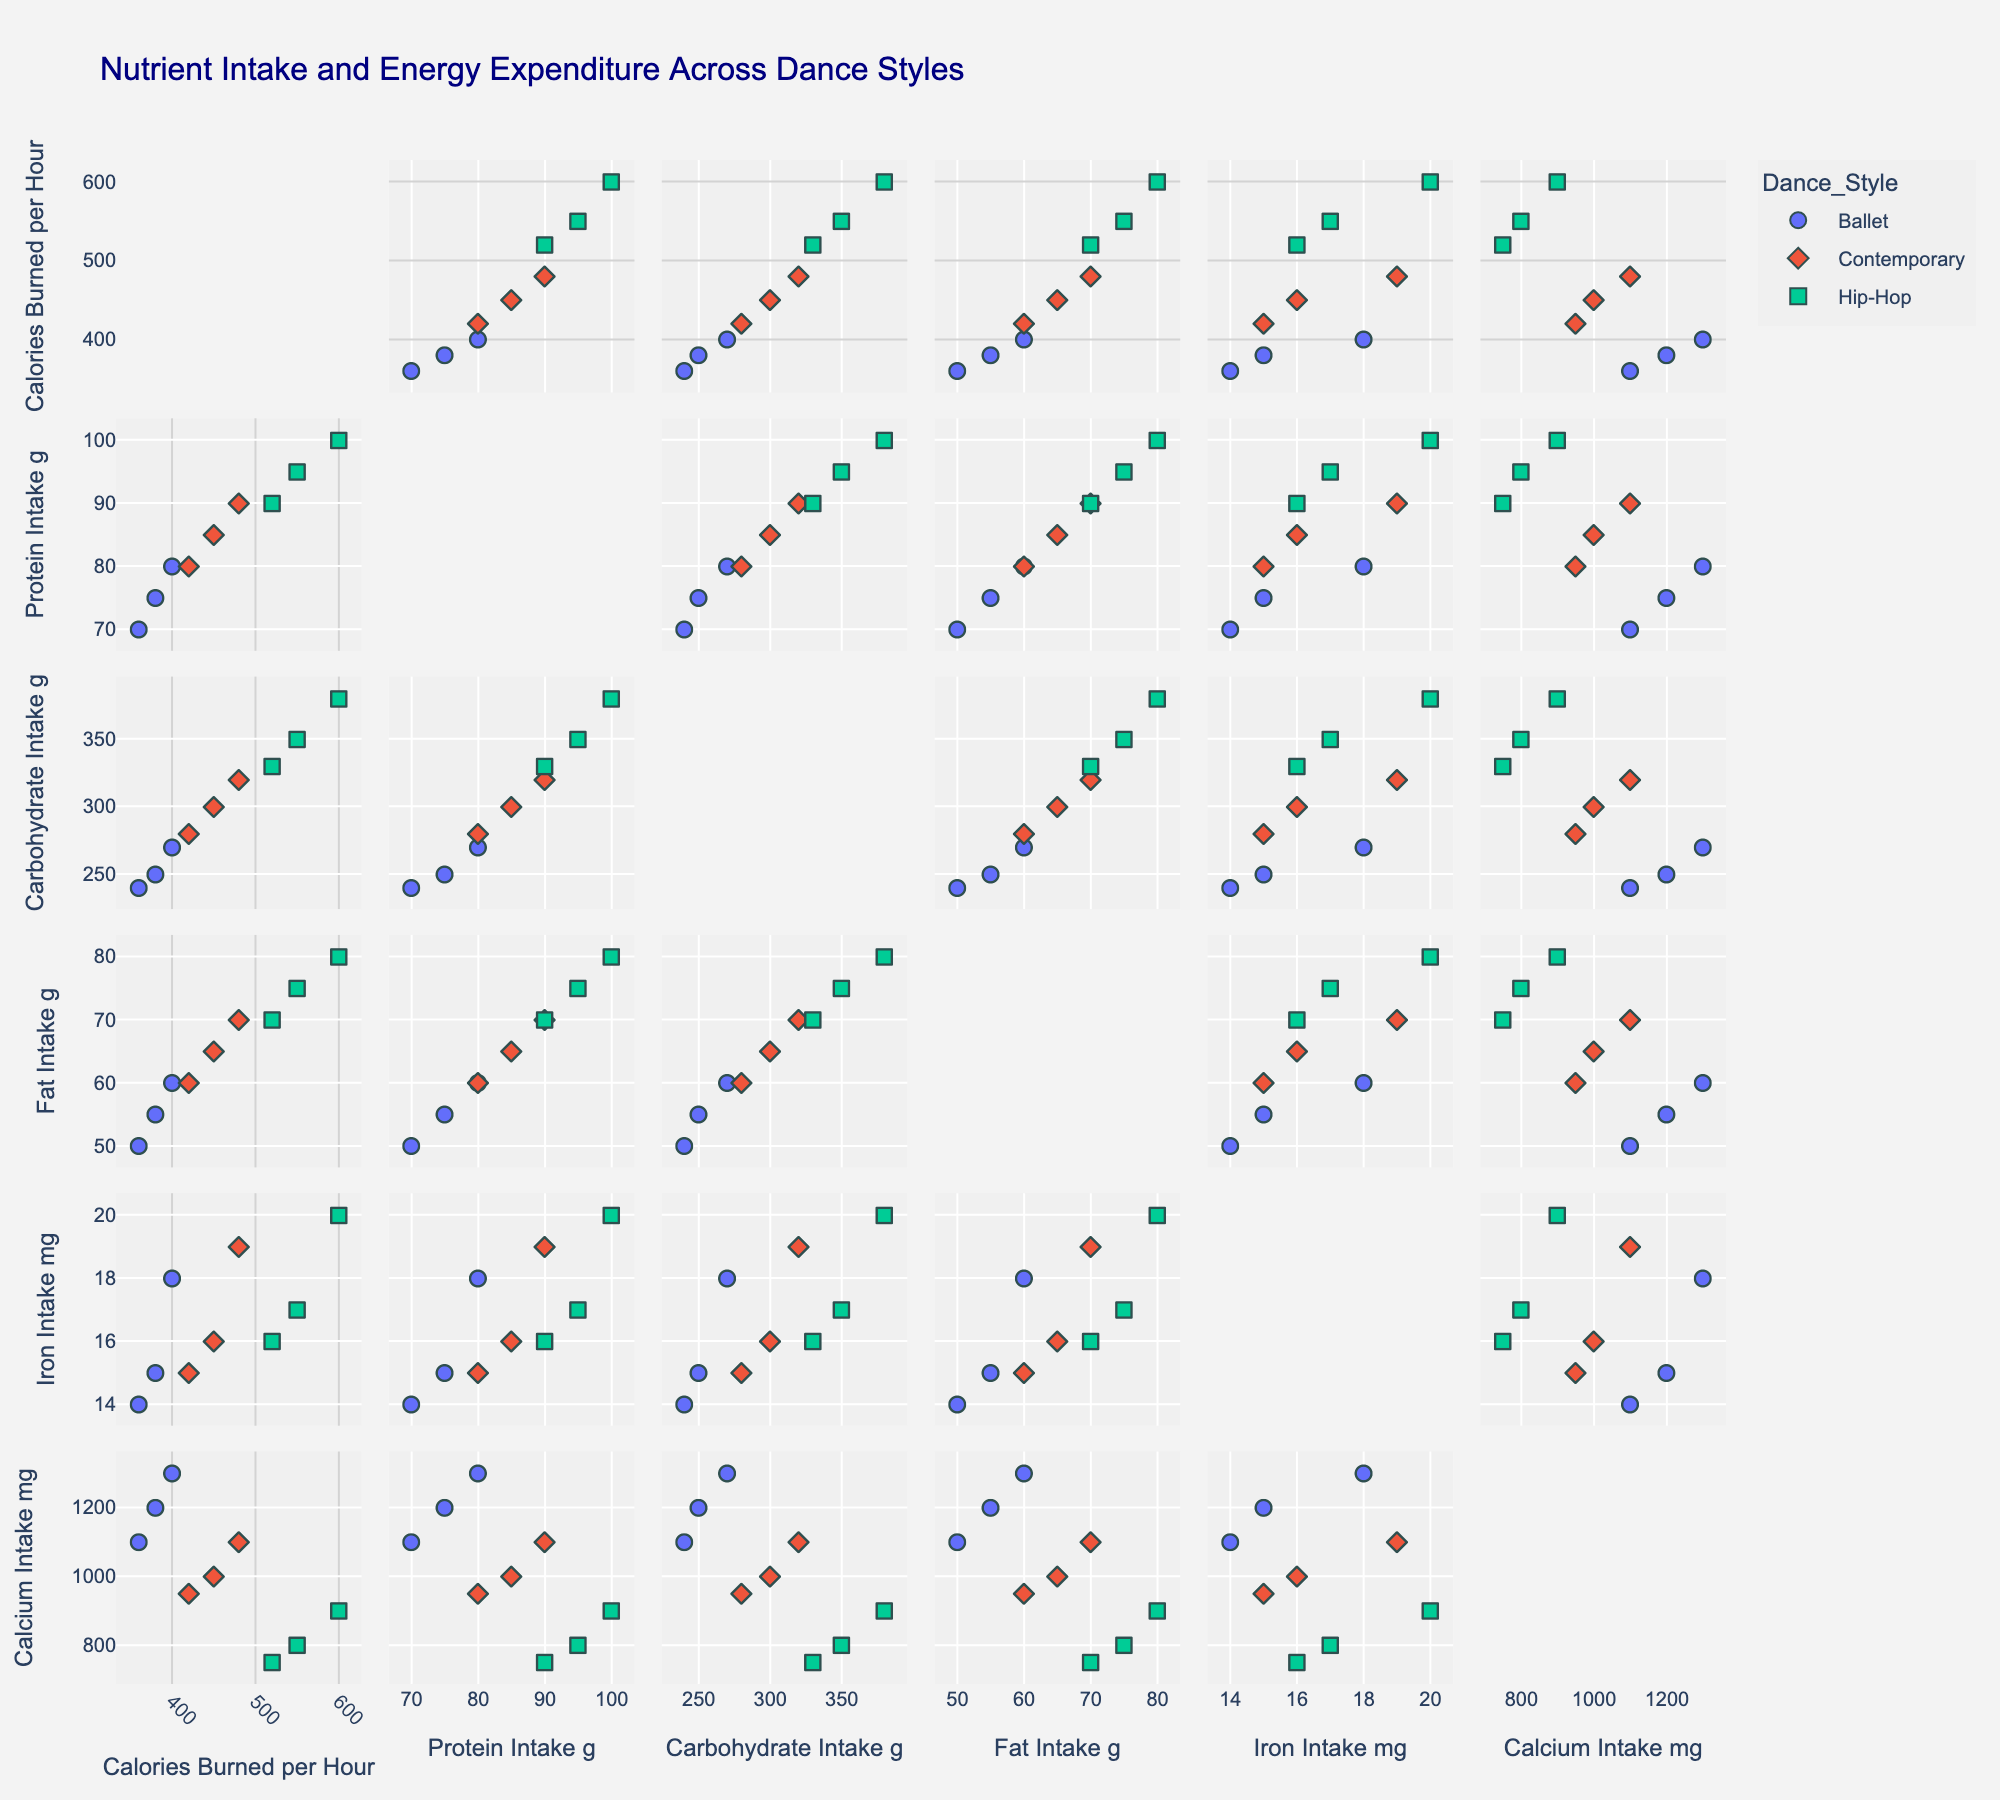What is the title of the scatterplot matrix? The title is displayed at the top of the figure and mentions the theme of the dataset.
Answer: Nutrient Intake and Energy Expenditure Across Dance Styles Which dance style has the highest calories burned per hour? To identify the dance style with the highest calories burned per hour, look at the scatterplot for the 'Calories Burned per Hour' dimension and find the highest point, then note its corresponding dance style.
Answer: Hip-Hop What is the average protein intake for ballet dancers? To compute the average protein intake for ballet dancers, find all the protein intake values for ballet and calculate the mean: (75 + 80 + 70) / 3.
Answer: 75 g Is there any correlation between carbohydrate intake and calories burned per hour for contemporary dancers? Look at the scatterplot for contemporary dancers between 'Carbohydrate Intake' and 'Calories Burned per Hour'. Determine if the points form any noticeable trend or pattern.
Answer: Yes, there is a positive correlation Which dance style has the widest range of calcium intake? Examine the 'Calcium Intake' dimension for all dance styles and compare the range (difference between maximum and minimum values) for each style.
Answer: Ballet How do ballet and hip-hop dancers compare in iron intake? Compare the points for iron intake in ballet and hip-hop dancers by looking at the 'Iron Intake' axis and noting the range and average values for each dance style.
Answer: Hip-Hop generally has higher iron intake than Ballet What is the median fat intake across all dancers? List all the 'Fat Intake' values: [55, 60, 50, 65, 70, 60, 75, 80, 70], sort them and find the middle value. Median is the fifth value in the sorted list.
Answer: 65 g Do contemporary dancers have a higher average carbohydrate intake compared to hip-hop dancers? Calculate the average carbohydrate intake for contemporary dancers: (300 + 320 + 280) / 3 and for hip-hop dancers: (350 + 380 + 330) / 3. Compare the two averages.
Answer: No What is the relationship between protein intake and calories burned per hour in hip-hop dancers? Examine the scatterplot between 'Protein Intake' and 'Calories Burned per Hour' for hip-hop dancers. Observe if higher protein intake corresponds to higher calories burned.
Answer: Positive correlation How does the protein intake of the highest calorie burner in hip-hop compare to the lowest in ballet? Find the highest 'Calories Burned per Hour' in hip-hop and lowest in ballet and compare their corresponding 'Protein Intake' values. The highest for hip-hop is 600 and the lowest for ballet is 360. Their respective protein intakes are 100g and 70g.
Answer: Hip-Hop is higher 